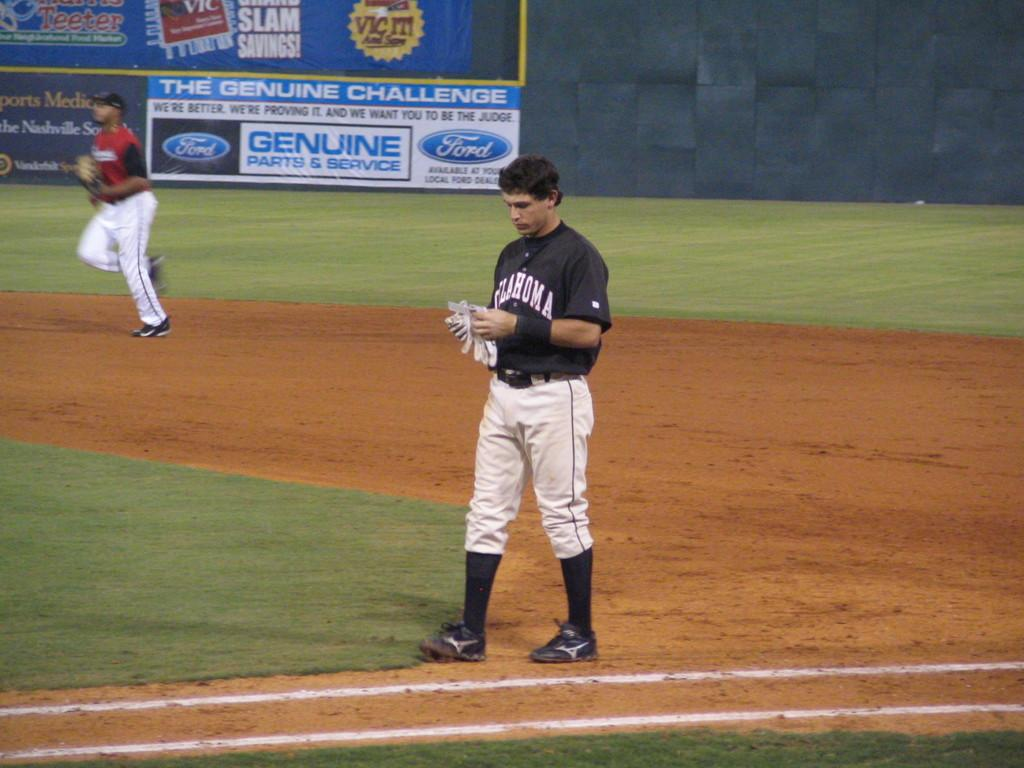<image>
Provide a brief description of the given image. Baseball player wearing a jersey which says Oklahoma on it. 